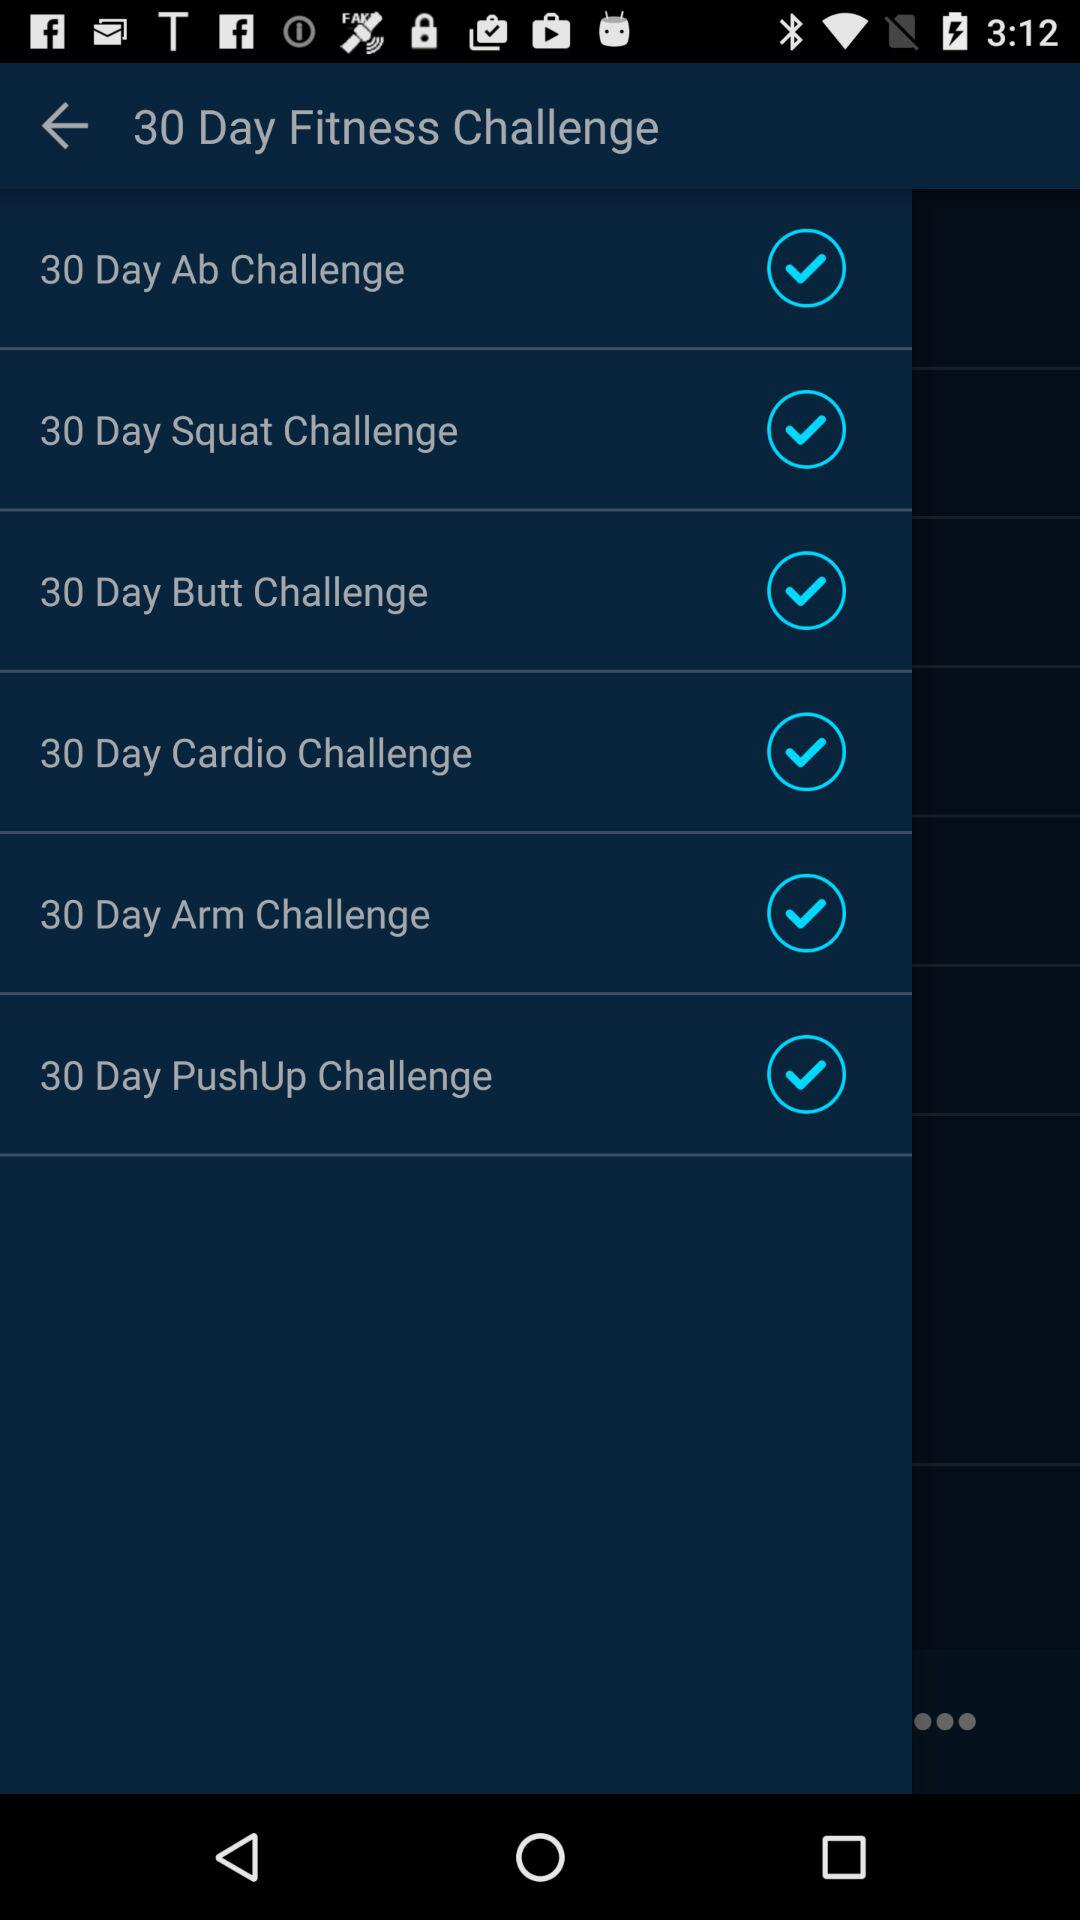How many fitness challenges are there?
Answer the question using a single word or phrase. 6 